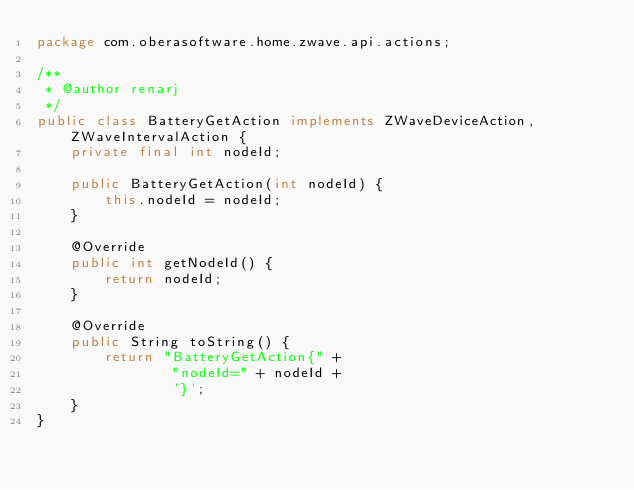<code> <loc_0><loc_0><loc_500><loc_500><_Java_>package com.oberasoftware.home.zwave.api.actions;

/**
 * @author renarj
 */
public class BatteryGetAction implements ZWaveDeviceAction, ZWaveIntervalAction {
    private final int nodeId;

    public BatteryGetAction(int nodeId) {
        this.nodeId = nodeId;
    }

    @Override
    public int getNodeId() {
        return nodeId;
    }

    @Override
    public String toString() {
        return "BatteryGetAction{" +
                "nodeId=" + nodeId +
                '}';
    }
}
</code> 